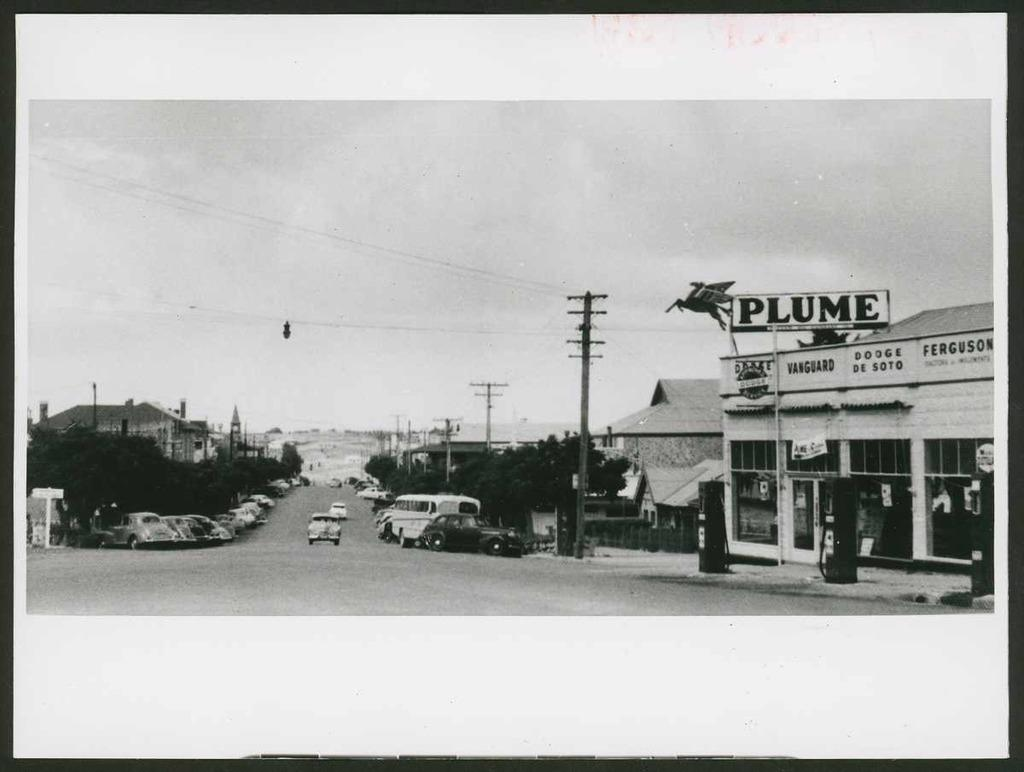<image>
Present a compact description of the photo's key features. A black and white photo with a place called Plume on the right. 